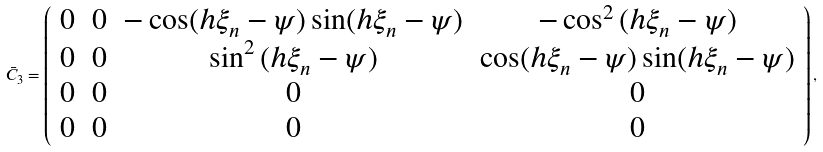<formula> <loc_0><loc_0><loc_500><loc_500>\bar { C } _ { 3 } = \left ( \begin{array} { c c c c } 0 & 0 & - \cos ( { h \xi _ { n } - \psi } ) \sin ( { h \xi _ { n } - \psi } ) & - \cos ^ { 2 } { ( { h \xi _ { n } - \psi } ) } \\ 0 & 0 & \sin ^ { 2 } { ( { h \xi _ { n } - \psi } ) } & \cos ( { h \xi _ { n } - \psi } ) \sin ( { h \xi _ { n } - \psi } ) \\ 0 & 0 & 0 & 0 \\ 0 & 0 & 0 & 0 \\ \end{array} \right ) ,</formula> 